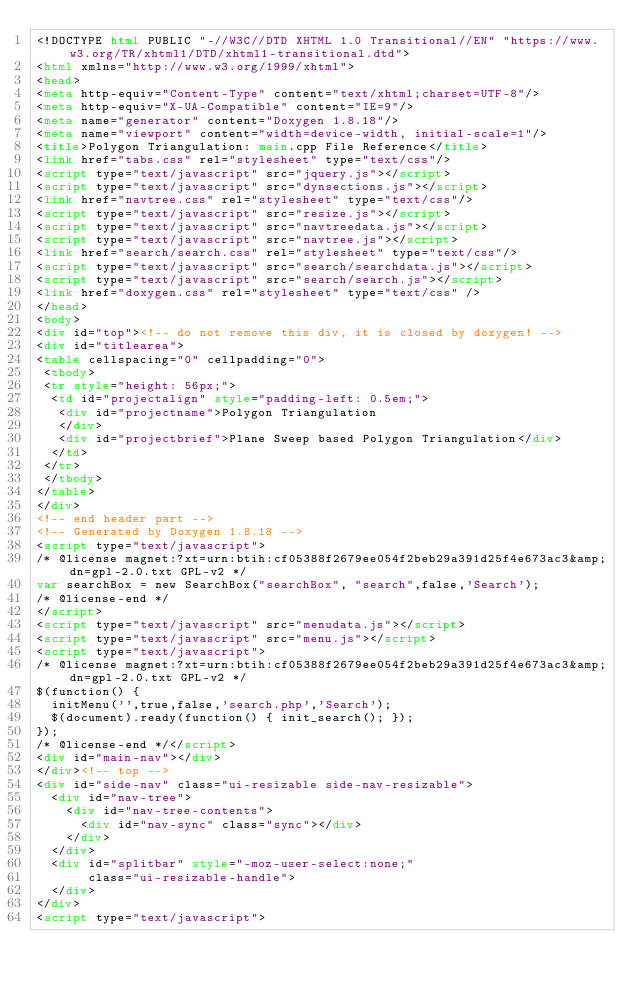Convert code to text. <code><loc_0><loc_0><loc_500><loc_500><_HTML_><!DOCTYPE html PUBLIC "-//W3C//DTD XHTML 1.0 Transitional//EN" "https://www.w3.org/TR/xhtml1/DTD/xhtml1-transitional.dtd">
<html xmlns="http://www.w3.org/1999/xhtml">
<head>
<meta http-equiv="Content-Type" content="text/xhtml;charset=UTF-8"/>
<meta http-equiv="X-UA-Compatible" content="IE=9"/>
<meta name="generator" content="Doxygen 1.8.18"/>
<meta name="viewport" content="width=device-width, initial-scale=1"/>
<title>Polygon Triangulation: main.cpp File Reference</title>
<link href="tabs.css" rel="stylesheet" type="text/css"/>
<script type="text/javascript" src="jquery.js"></script>
<script type="text/javascript" src="dynsections.js"></script>
<link href="navtree.css" rel="stylesheet" type="text/css"/>
<script type="text/javascript" src="resize.js"></script>
<script type="text/javascript" src="navtreedata.js"></script>
<script type="text/javascript" src="navtree.js"></script>
<link href="search/search.css" rel="stylesheet" type="text/css"/>
<script type="text/javascript" src="search/searchdata.js"></script>
<script type="text/javascript" src="search/search.js"></script>
<link href="doxygen.css" rel="stylesheet" type="text/css" />
</head>
<body>
<div id="top"><!-- do not remove this div, it is closed by doxygen! -->
<div id="titlearea">
<table cellspacing="0" cellpadding="0">
 <tbody>
 <tr style="height: 56px;">
  <td id="projectalign" style="padding-left: 0.5em;">
   <div id="projectname">Polygon Triangulation
   </div>
   <div id="projectbrief">Plane Sweep based Polygon Triangulation</div>
  </td>
 </tr>
 </tbody>
</table>
</div>
<!-- end header part -->
<!-- Generated by Doxygen 1.8.18 -->
<script type="text/javascript">
/* @license magnet:?xt=urn:btih:cf05388f2679ee054f2beb29a391d25f4e673ac3&amp;dn=gpl-2.0.txt GPL-v2 */
var searchBox = new SearchBox("searchBox", "search",false,'Search');
/* @license-end */
</script>
<script type="text/javascript" src="menudata.js"></script>
<script type="text/javascript" src="menu.js"></script>
<script type="text/javascript">
/* @license magnet:?xt=urn:btih:cf05388f2679ee054f2beb29a391d25f4e673ac3&amp;dn=gpl-2.0.txt GPL-v2 */
$(function() {
  initMenu('',true,false,'search.php','Search');
  $(document).ready(function() { init_search(); });
});
/* @license-end */</script>
<div id="main-nav"></div>
</div><!-- top -->
<div id="side-nav" class="ui-resizable side-nav-resizable">
  <div id="nav-tree">
    <div id="nav-tree-contents">
      <div id="nav-sync" class="sync"></div>
    </div>
  </div>
  <div id="splitbar" style="-moz-user-select:none;" 
       class="ui-resizable-handle">
  </div>
</div>
<script type="text/javascript"></code> 